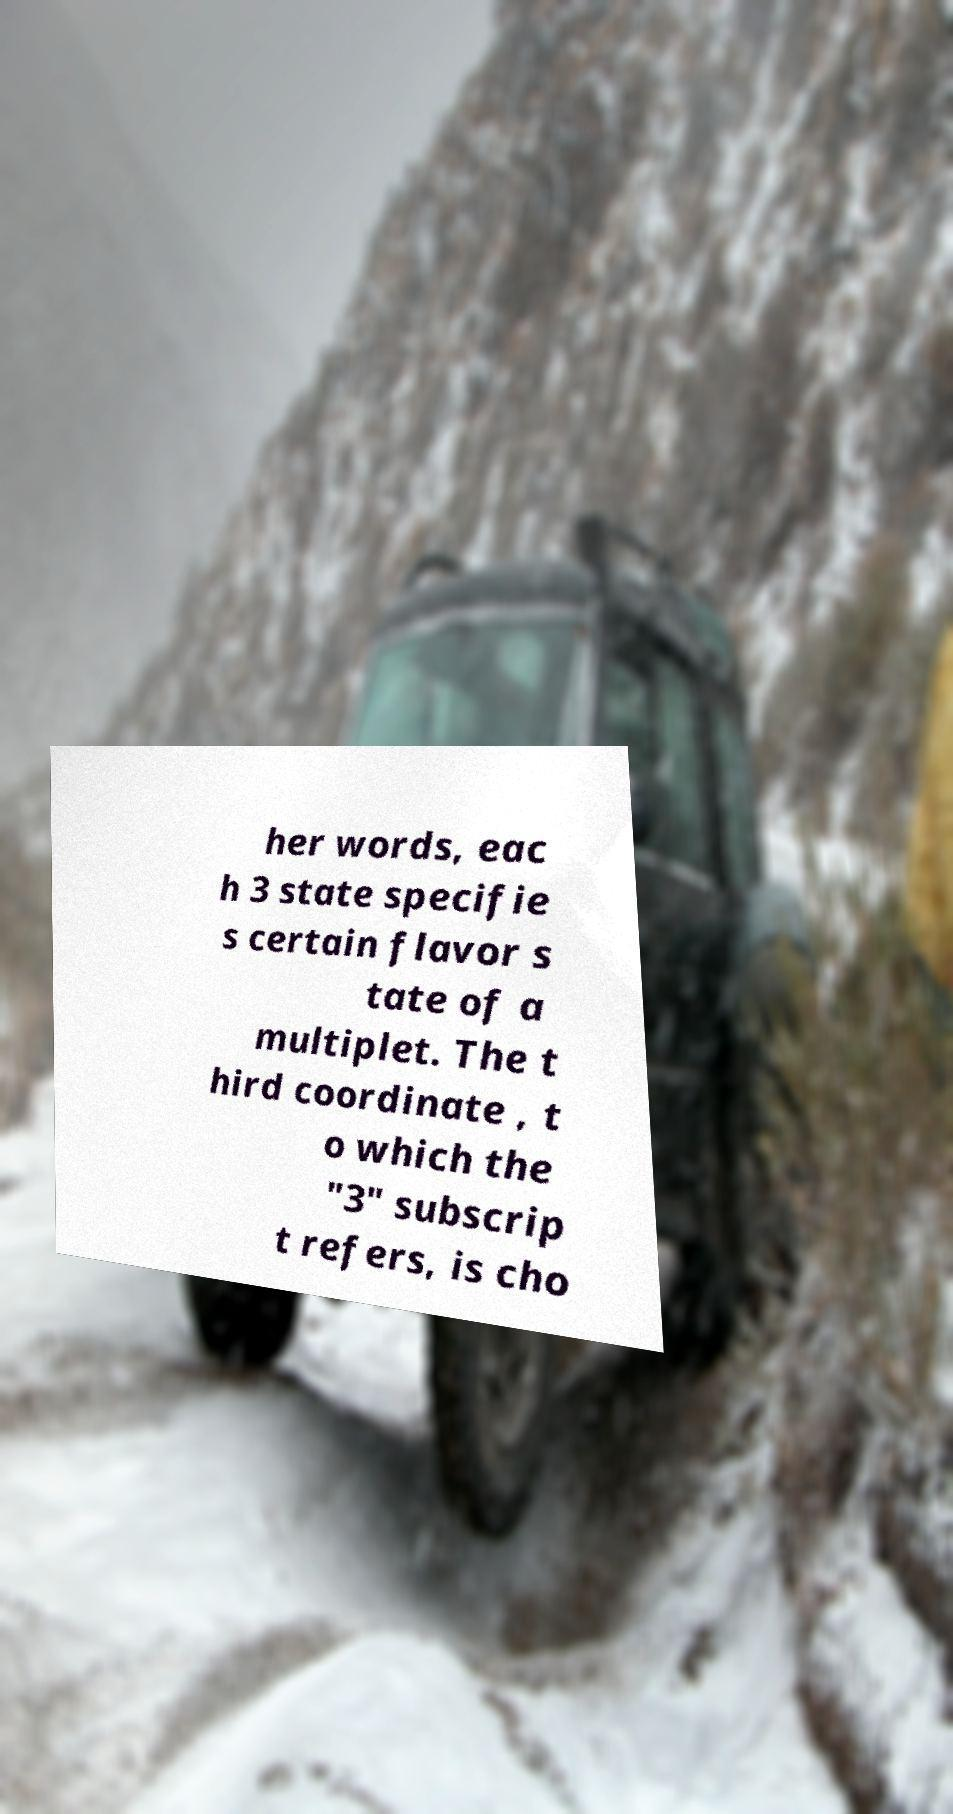There's text embedded in this image that I need extracted. Can you transcribe it verbatim? her words, eac h 3 state specifie s certain flavor s tate of a multiplet. The t hird coordinate , t o which the "3" subscrip t refers, is cho 